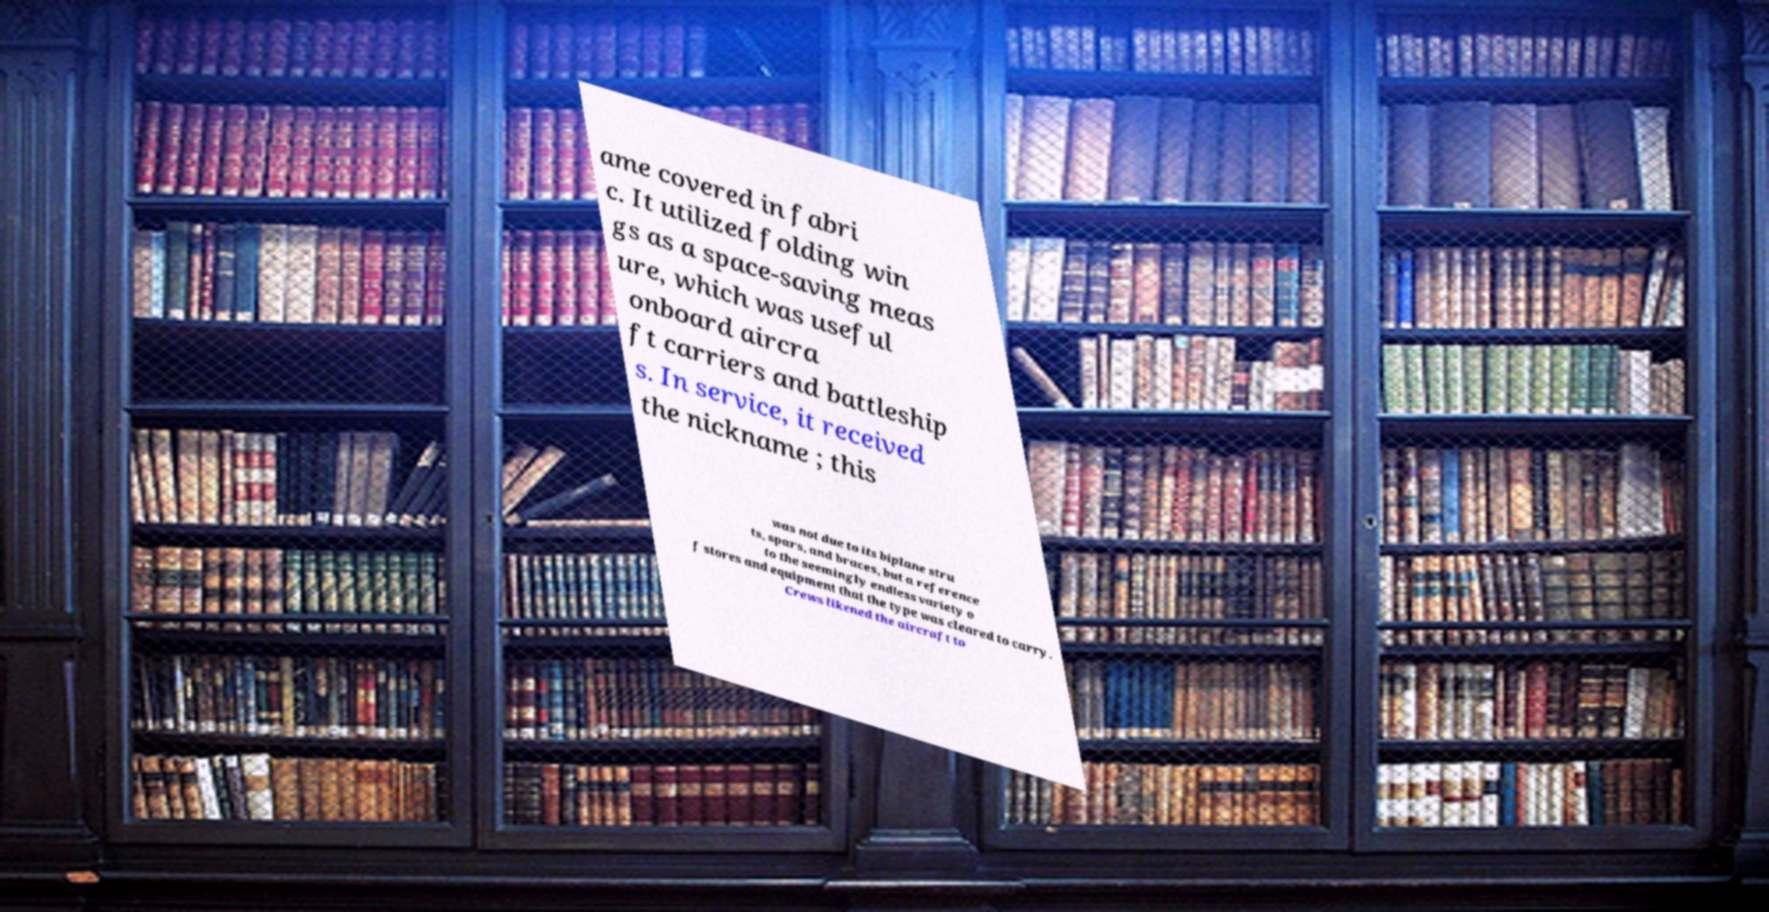There's text embedded in this image that I need extracted. Can you transcribe it verbatim? ame covered in fabri c. It utilized folding win gs as a space-saving meas ure, which was useful onboard aircra ft carriers and battleship s. In service, it received the nickname ; this was not due to its biplane stru ts, spars, and braces, but a reference to the seemingly endless variety o f stores and equipment that the type was cleared to carry. Crews likened the aircraft to 